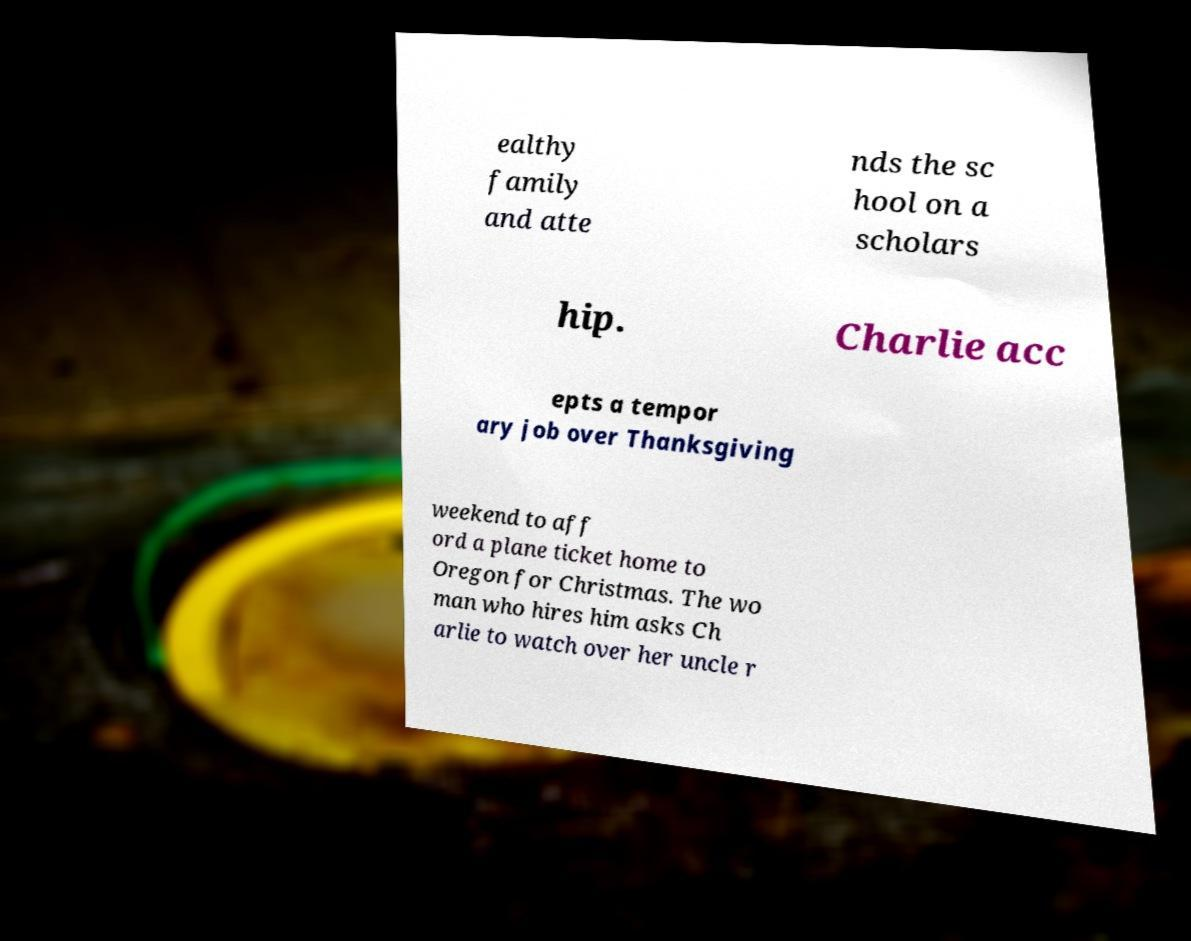Please read and relay the text visible in this image. What does it say? ealthy family and atte nds the sc hool on a scholars hip. Charlie acc epts a tempor ary job over Thanksgiving weekend to aff ord a plane ticket home to Oregon for Christmas. The wo man who hires him asks Ch arlie to watch over her uncle r 